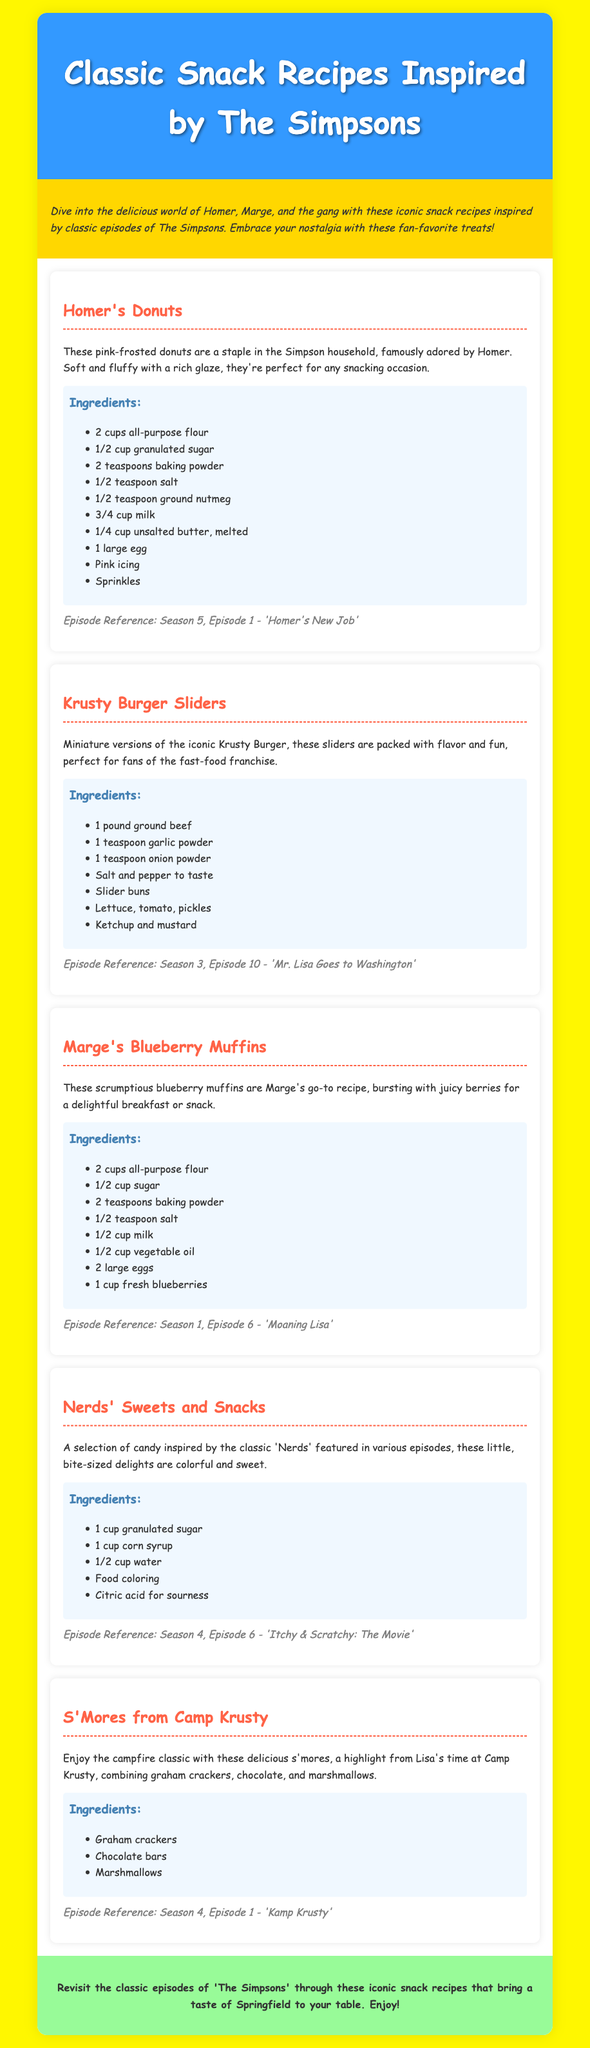What is the title of this document? The title of the document is provided in the header section, which is "Classic Snack Recipes Inspired by The Simpsons."
Answer: Classic Snack Recipes Inspired by The Simpsons What is the first snack recipe listed? The first snack recipe listed is shown in the document with the heading format, which states "Homer's Donuts."
Answer: Homer's Donuts Which season and episode reference is associated with Marge's Blueberry Muffins? The season and episode reference for Marge's Blueberry Muffins is mentioned in the episode section, indicating the details, which is "Season 1, Episode 6 - 'Moaning Lisa'."
Answer: Season 1, Episode 6 - 'Moaning Lisa' How many ingredients are listed for the Krusty Burger Sliders? The number of ingredients for the Krusty Burger Sliders can be counted from the ingredients section where the items are enumerated. There are seven ingredients.
Answer: 7 What is the background color of the document? The background color of the body section is specified in the style, which is "#FFF700."
Answer: #FFF700 What is the ingredient used for "sourness" in Nerds' Sweets and Snacks? The document mentions "Citric acid for sourness" in the ingredients, making this clear.
Answer: Citric acid Where can you find the reference to the campfire classic recipe? The reference can be found in the description of the snack that mentions "s'mores, a highlight from Lisa's time at Camp Krusty."
Answer: Kamp Krusty What type of font is used in the document? The font type for the body text is declared in the CSS, which is "Comic Sans MS."
Answer: Comic Sans MS How many colorful, bite-sized delights are part of the Nerds' Sweets and Snacks recipe? The selection of candy mentioned refers generally to "these little, bite-sized delights," but no specific quantity is provided, implying it's varied.
Answer: N/A 